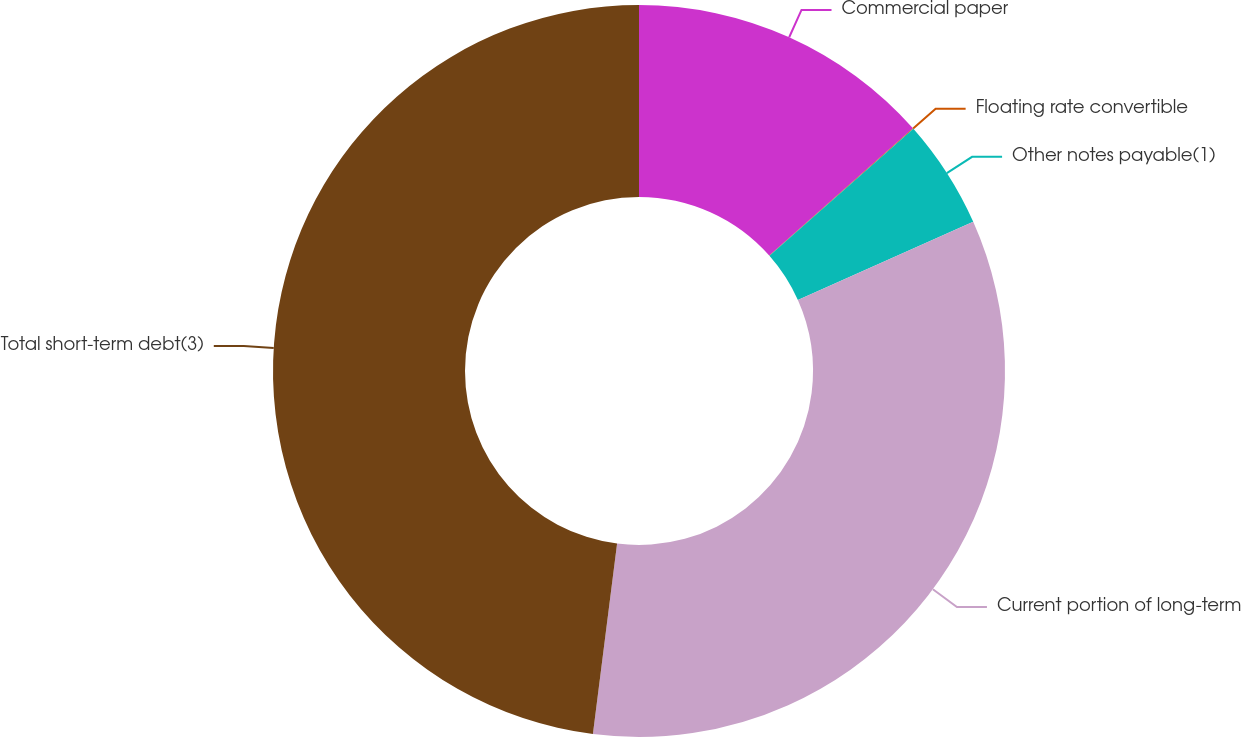<chart> <loc_0><loc_0><loc_500><loc_500><pie_chart><fcel>Commercial paper<fcel>Floating rate convertible<fcel>Other notes payable(1)<fcel>Current portion of long-term<fcel>Total short-term debt(3)<nl><fcel>13.46%<fcel>0.03%<fcel>4.83%<fcel>33.69%<fcel>47.99%<nl></chart> 